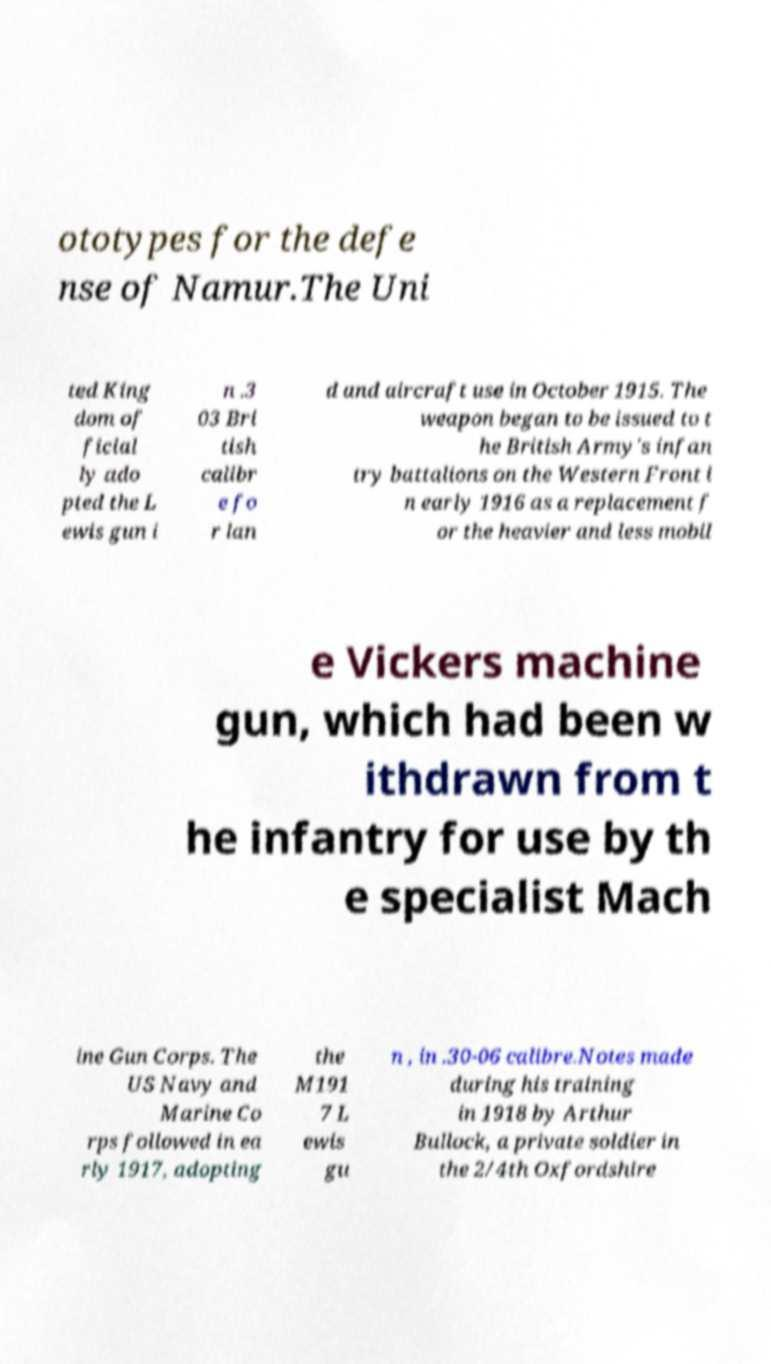Could you extract and type out the text from this image? ototypes for the defe nse of Namur.The Uni ted King dom of ficial ly ado pted the L ewis gun i n .3 03 Bri tish calibr e fo r lan d and aircraft use in October 1915. The weapon began to be issued to t he British Army's infan try battalions on the Western Front i n early 1916 as a replacement f or the heavier and less mobil e Vickers machine gun, which had been w ithdrawn from t he infantry for use by th e specialist Mach ine Gun Corps. The US Navy and Marine Co rps followed in ea rly 1917, adopting the M191 7 L ewis gu n , in .30-06 calibre.Notes made during his training in 1918 by Arthur Bullock, a private soldier in the 2/4th Oxfordshire 